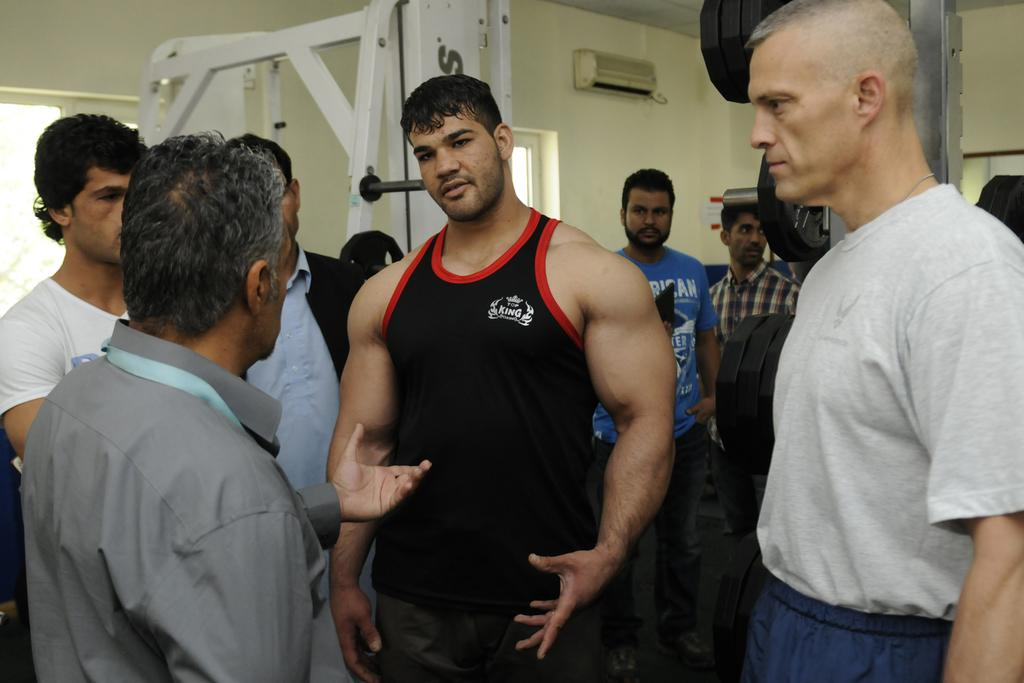How many people are visible in the image? There are many people in the image. What type of objects can be seen among the people? There are metallic objects in the image. Can you describe any objects on the wall? There is an object on the wall. What is located on the right side of the image? There is a poster on the right side of the image. Can you hear the sound of the waves in the image? There is no reference to waves or any sounds in the image, so it's not possible to determine if any sounds can be heard. 